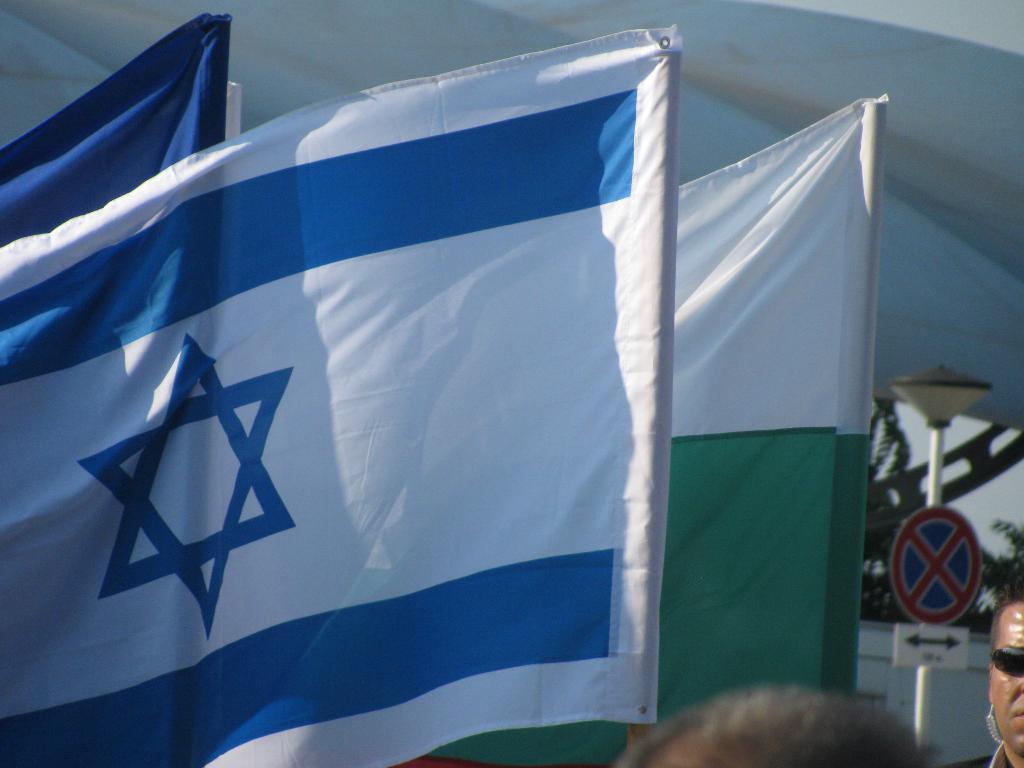In one or two sentences, can you explain what this image depicts? In this image we can see flags, pole, boards, wall, sky, branches, and two persons who are truncated. There is a white background. 